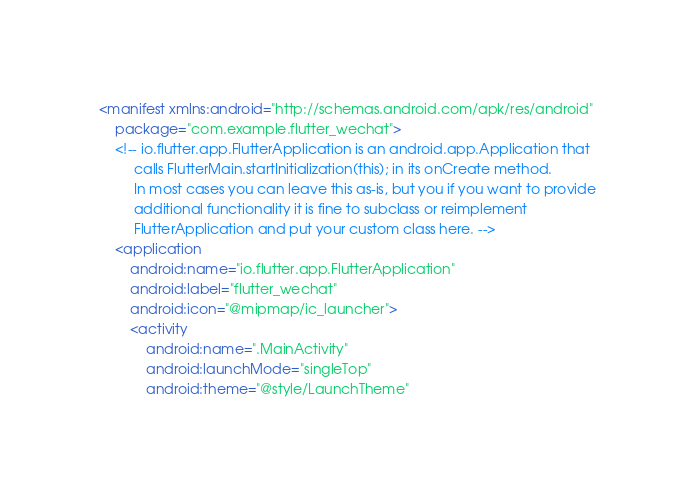<code> <loc_0><loc_0><loc_500><loc_500><_XML_><manifest xmlns:android="http://schemas.android.com/apk/res/android"
    package="com.example.flutter_wechat">
    <!-- io.flutter.app.FlutterApplication is an android.app.Application that
         calls FlutterMain.startInitialization(this); in its onCreate method.
         In most cases you can leave this as-is, but you if you want to provide
         additional functionality it is fine to subclass or reimplement
         FlutterApplication and put your custom class here. -->
    <application
        android:name="io.flutter.app.FlutterApplication"
        android:label="flutter_wechat"
        android:icon="@mipmap/ic_launcher">
        <activity
            android:name=".MainActivity"
            android:launchMode="singleTop"
            android:theme="@style/LaunchTheme"</code> 